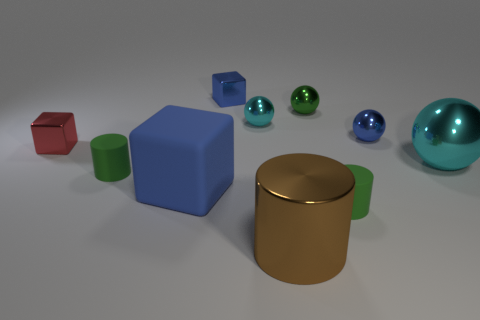Subtract all balls. How many objects are left? 6 Subtract all tiny cyan metallic balls. Subtract all balls. How many objects are left? 5 Add 2 tiny green metallic spheres. How many tiny green metallic spheres are left? 3 Add 1 big blue cubes. How many big blue cubes exist? 2 Subtract 0 yellow cubes. How many objects are left? 10 